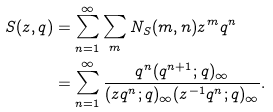<formula> <loc_0><loc_0><loc_500><loc_500>S ( z , q ) & = \sum _ { n = 1 } ^ { \infty } \sum _ { m } N _ { S } ( m , n ) z ^ { m } q ^ { n } \\ & = \sum _ { n = 1 } ^ { \infty } \frac { q ^ { n } ( q ^ { n + 1 } ; q ) _ { \infty } } { ( z q ^ { n } ; q ) _ { \infty } ( z ^ { - 1 } q ^ { n } ; q ) _ { \infty } } .</formula> 